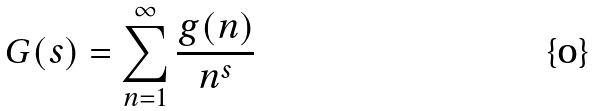Convert formula to latex. <formula><loc_0><loc_0><loc_500><loc_500>G ( s ) = \sum _ { n = 1 } ^ { \infty } \frac { g ( n ) } { n ^ { s } }</formula> 